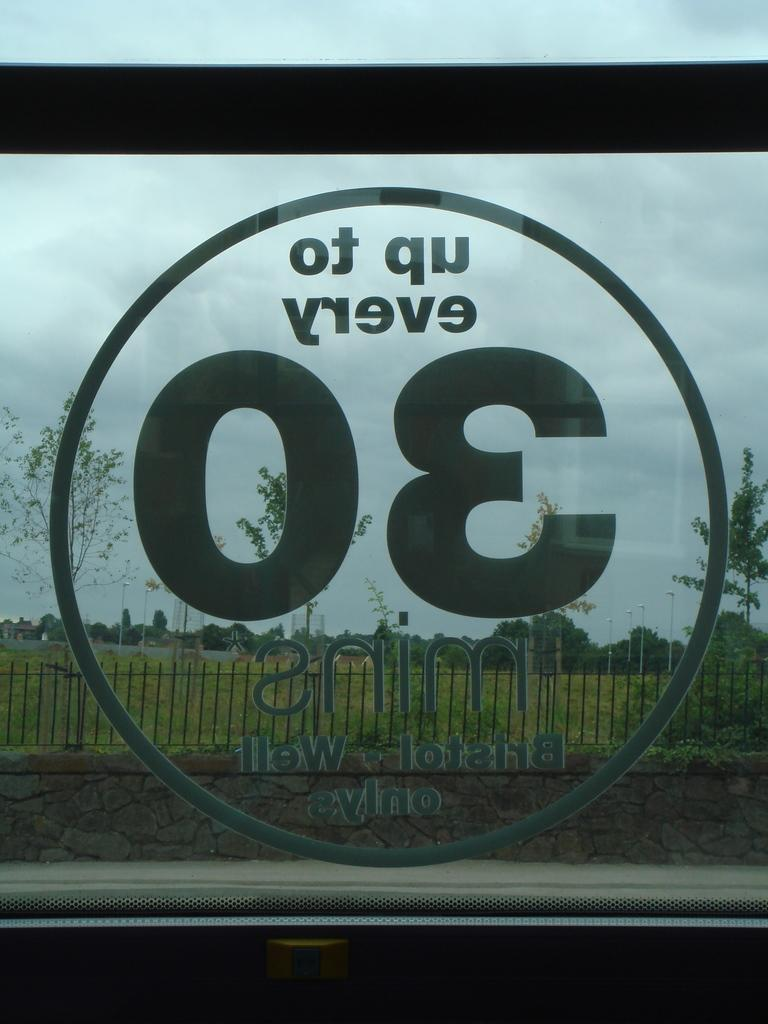What is on the window of the vehicle in the image? There is a sticker on the window of a vehicle in the image. What can be seen in the background of the image? In the background of the image, there is a wall, iron grills, lights, poles, trees, and the sky. How many different elements can be seen in the background of the image? There are seven different elements visible in the background of the image. What type of trousers is the sticker wearing in the image? The sticker is not a person and therefore cannot wear trousers. The sticker is simply an image or design on the window of the vehicle. 